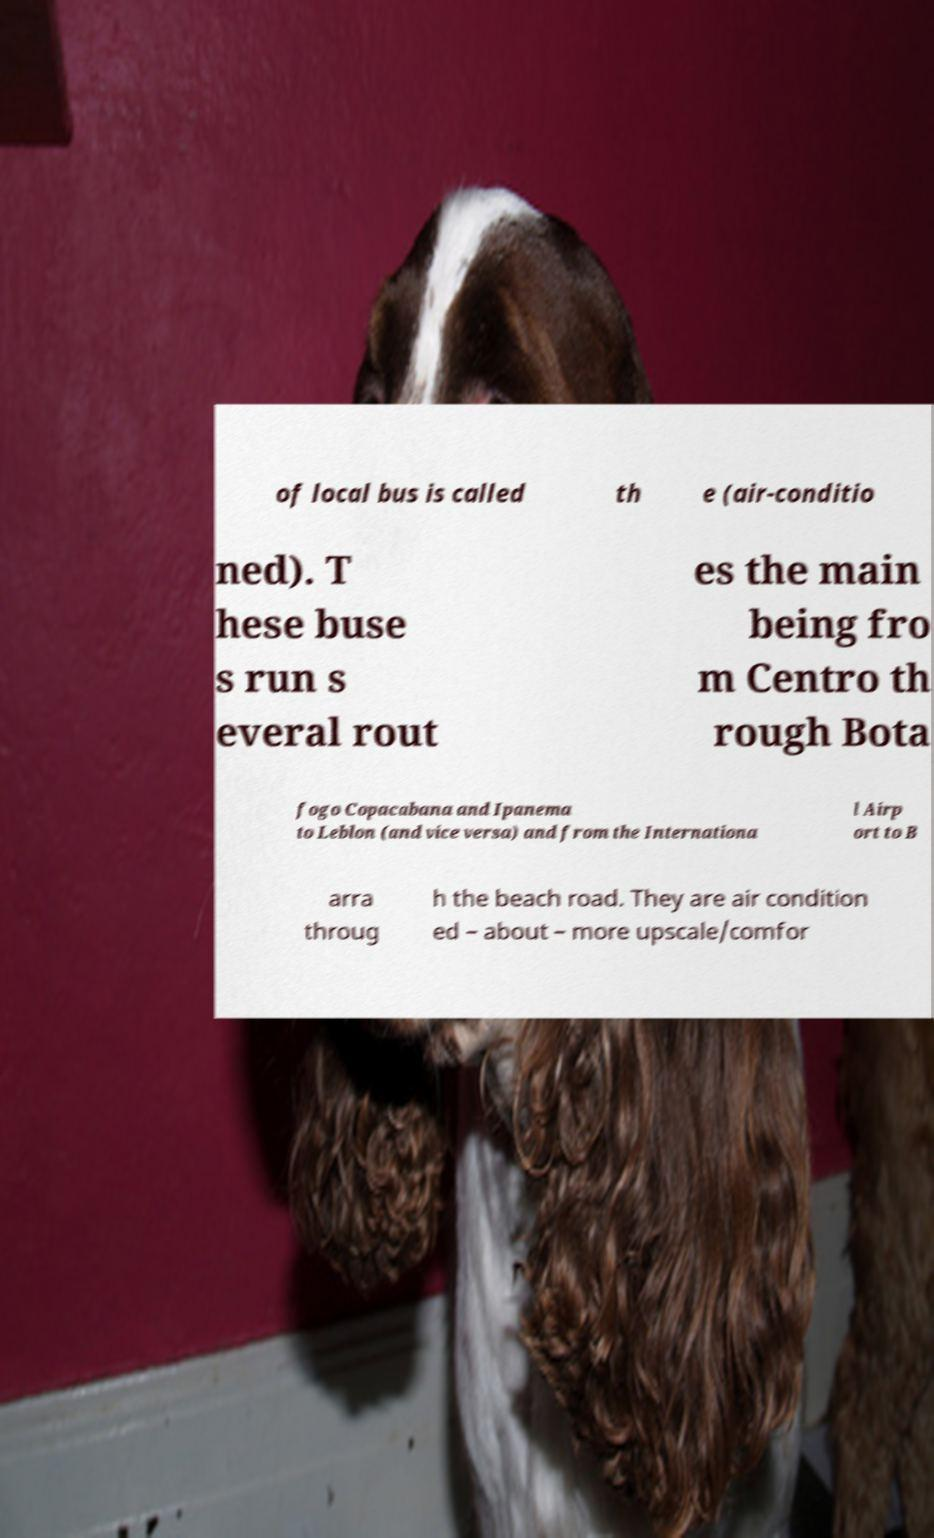Could you extract and type out the text from this image? of local bus is called th e (air-conditio ned). T hese buse s run s everal rout es the main being fro m Centro th rough Bota fogo Copacabana and Ipanema to Leblon (and vice versa) and from the Internationa l Airp ort to B arra throug h the beach road. They are air condition ed – about – more upscale/comfor 